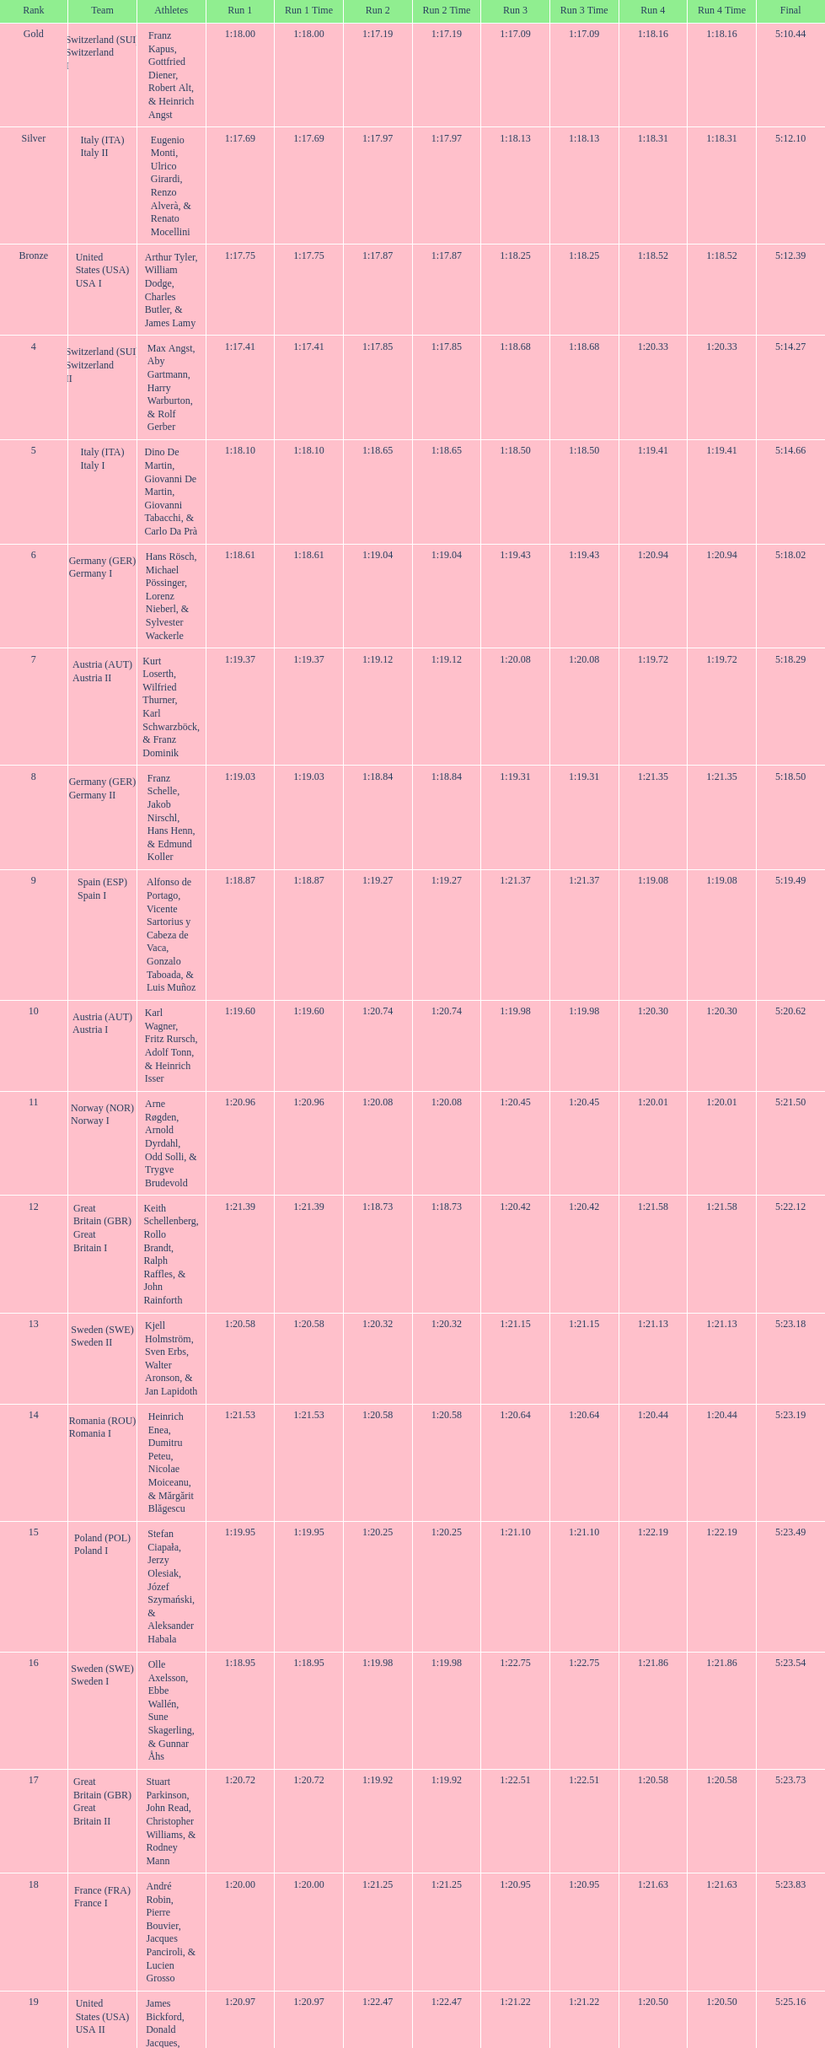How many teams did germany have? 2. 